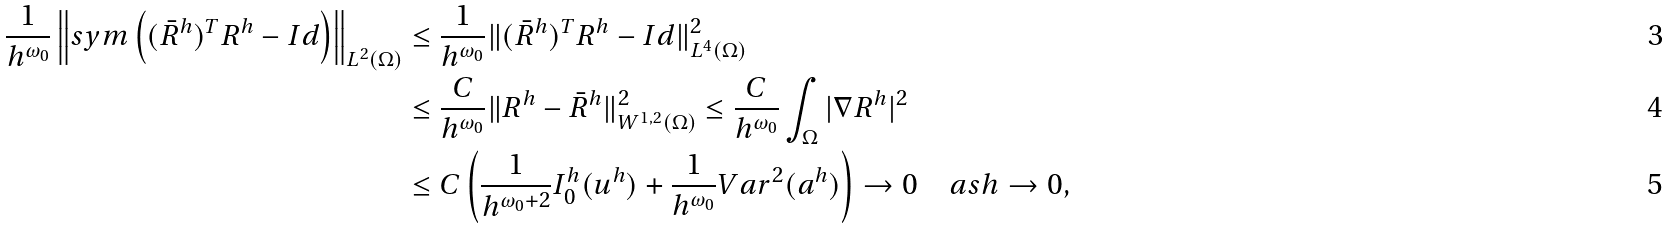<formula> <loc_0><loc_0><loc_500><loc_500>\frac { 1 } { h ^ { \omega _ { 0 } } } \left \| s y m \left ( ( \bar { R } ^ { h } ) ^ { T } R ^ { h } - I d \right ) \right \| _ { L ^ { 2 } ( \Omega ) } & \leq \frac { 1 } { h ^ { \omega _ { 0 } } } \| ( \bar { R } ^ { h } ) ^ { T } R ^ { h } - I d \| ^ { 2 } _ { L ^ { 4 } ( \Omega ) } \\ & \leq \frac { C } { h ^ { \omega _ { 0 } } } \| R ^ { h } - \bar { R } ^ { h } \| ^ { 2 } _ { W ^ { 1 , 2 } ( \Omega ) } \leq \frac { C } { h ^ { \omega _ { 0 } } } \int _ { \Omega } | \nabla R ^ { h } | ^ { 2 } \\ & \leq C \left ( \frac { 1 } { h ^ { \omega _ { 0 } + 2 } } I _ { 0 } ^ { h } ( u ^ { h } ) + \frac { 1 } { h ^ { \omega _ { 0 } } } V a r ^ { 2 } ( a ^ { h } ) \right ) \rightarrow 0 \quad a s h \to 0 ,</formula> 